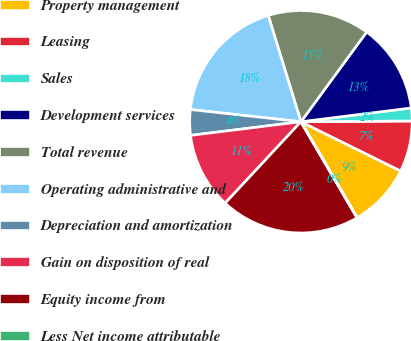Convert chart. <chart><loc_0><loc_0><loc_500><loc_500><pie_chart><fcel>Property management<fcel>Leasing<fcel>Sales<fcel>Development services<fcel>Total revenue<fcel>Operating administrative and<fcel>Depreciation and amortization<fcel>Gain on disposition of real<fcel>Equity income from<fcel>Less Net income attributable<nl><fcel>9.26%<fcel>7.41%<fcel>1.87%<fcel>12.96%<fcel>14.81%<fcel>18.5%<fcel>3.71%<fcel>11.11%<fcel>20.35%<fcel>0.02%<nl></chart> 